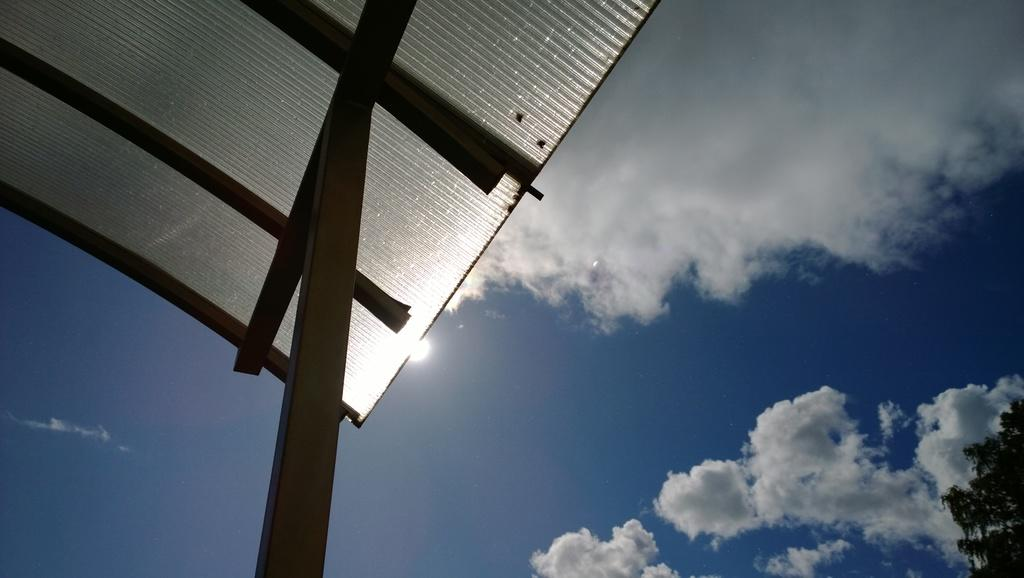What material covers the roof in the image? The roof in the image is covered with asbestos sheets. What can be seen at the top of the image? The sky is visible at the top of the image. What is present in the sky? Clouds are present in the sky. What type of vegetation is on the right side of the image at the bottom? There are trees on the right side of the image at the bottom. Is there a desk visible in the image? No, there is no desk present in the image. Is it raining in the image? The image does not show any indication of rain, so it cannot be determined from the image alone. 